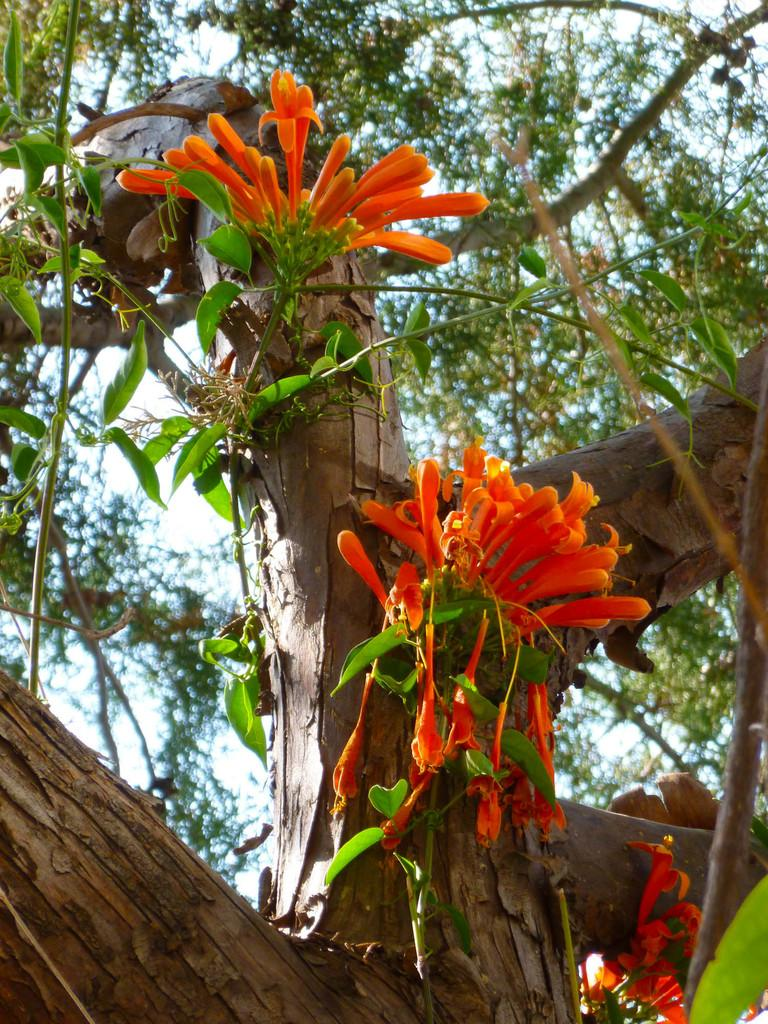What type of plants can be seen in the image? There are flowers in the image. What other natural elements are present in the image? There is a tree in the image. What can be seen in the background of the image? The sky is visible in the background of the image. When was the image taken? The image was taken during the day. What type of yoke is being used to maintain harmony among the cushions in the image? There is no yoke, harmony, or cushions present in the image; it features flowers and a tree with a visible sky in the background. 